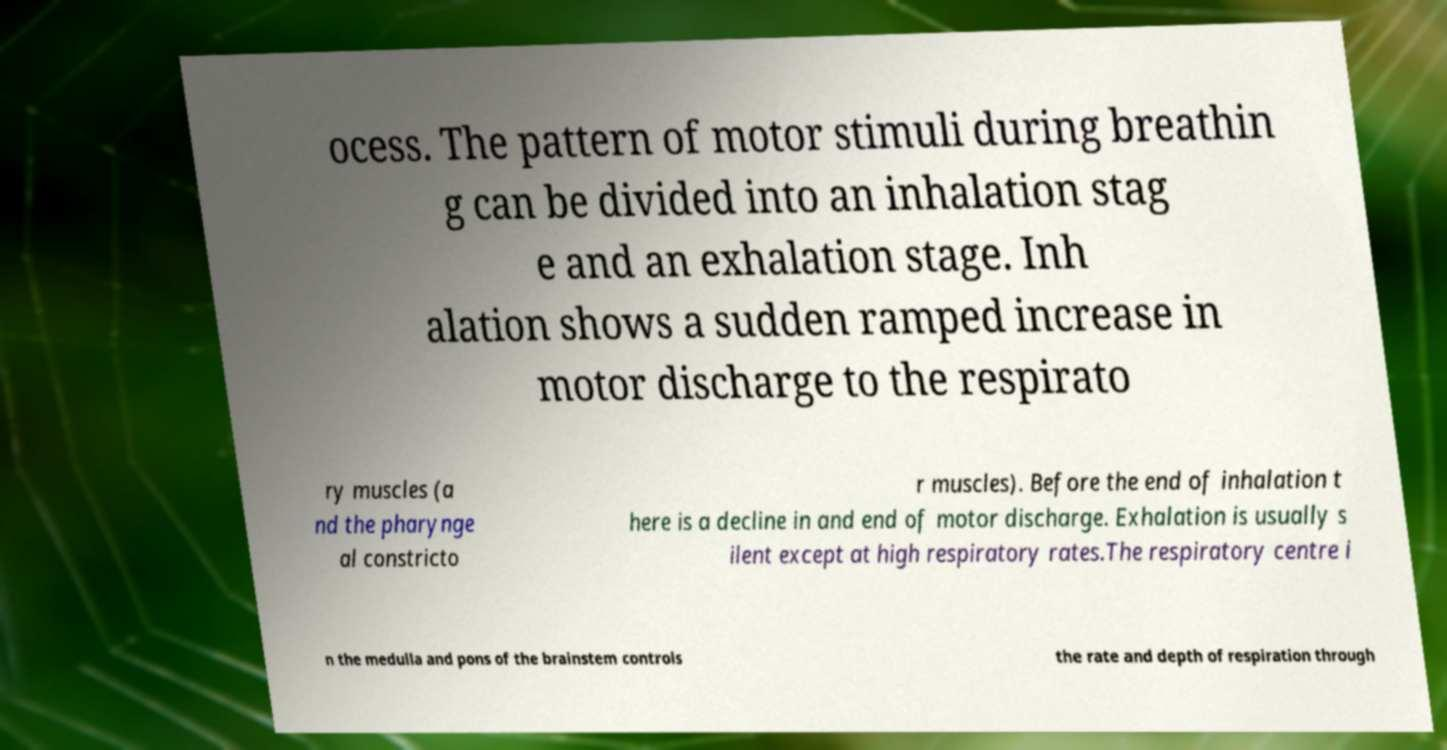Can you accurately transcribe the text from the provided image for me? ocess. The pattern of motor stimuli during breathin g can be divided into an inhalation stag e and an exhalation stage. Inh alation shows a sudden ramped increase in motor discharge to the respirato ry muscles (a nd the pharynge al constricto r muscles). Before the end of inhalation t here is a decline in and end of motor discharge. Exhalation is usually s ilent except at high respiratory rates.The respiratory centre i n the medulla and pons of the brainstem controls the rate and depth of respiration through 